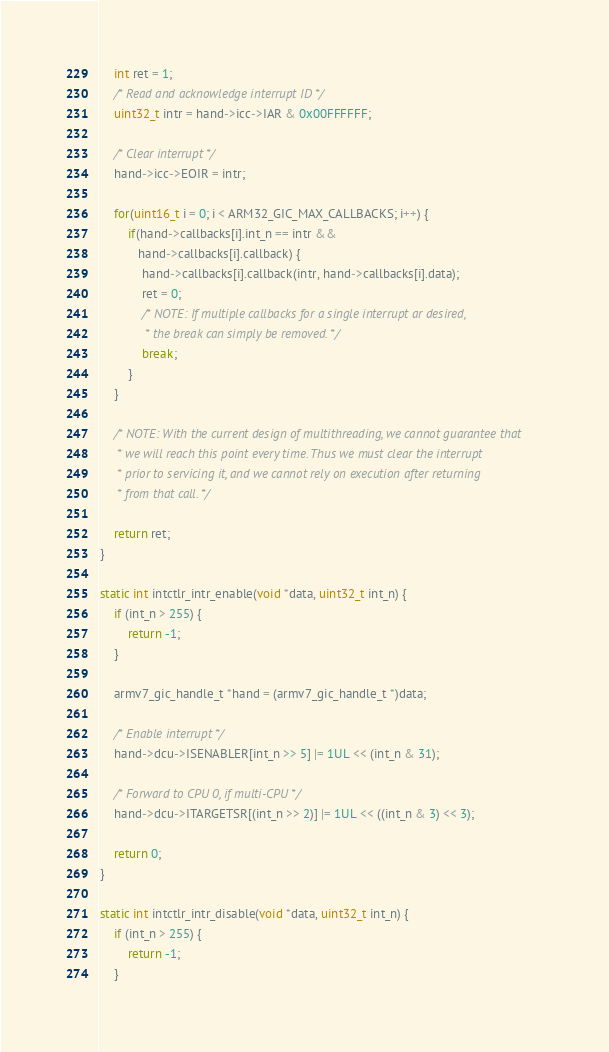Convert code to text. <code><loc_0><loc_0><loc_500><loc_500><_C_>    int ret = 1;
    /* Read and acknowledge interrupt ID */
    uint32_t intr = hand->icc->IAR & 0x00FFFFFF;

    /* Clear interrupt */
    hand->icc->EOIR = intr;

    for(uint16_t i = 0; i < ARM32_GIC_MAX_CALLBACKS; i++) {
        if(hand->callbacks[i].int_n == intr &&
           hand->callbacks[i].callback) {
            hand->callbacks[i].callback(intr, hand->callbacks[i].data);
            ret = 0;
            /* NOTE: If multiple callbacks for a single interrupt ar desired,
             * the break can simply be removed. */
            break;
        }
    }

    /* NOTE: With the current design of multithreading, we cannot guarantee that
     * we will reach this point every time. Thus we must clear the interrupt
     * prior to servicing it, and we cannot rely on execution after returning
     * from that call. */

    return ret;
}

static int intctlr_intr_enable(void *data, uint32_t int_n) {
    if (int_n > 255) {
        return -1;
    }

    armv7_gic_handle_t *hand = (armv7_gic_handle_t *)data;

    /* Enable interrupt */
    hand->dcu->ISENABLER[int_n >> 5] |= 1UL << (int_n & 31);

    /* Forward to CPU 0, if multi-CPU */
    hand->dcu->ITARGETSR[(int_n >> 2)] |= 1UL << ((int_n & 3) << 3);

    return 0;
}

static int intctlr_intr_disable(void *data, uint32_t int_n) {
    if (int_n > 255) {
        return -1;
    }
</code> 